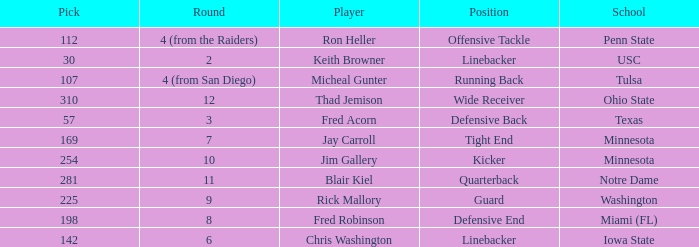What is the total pick number for a wide receiver? 1.0. 